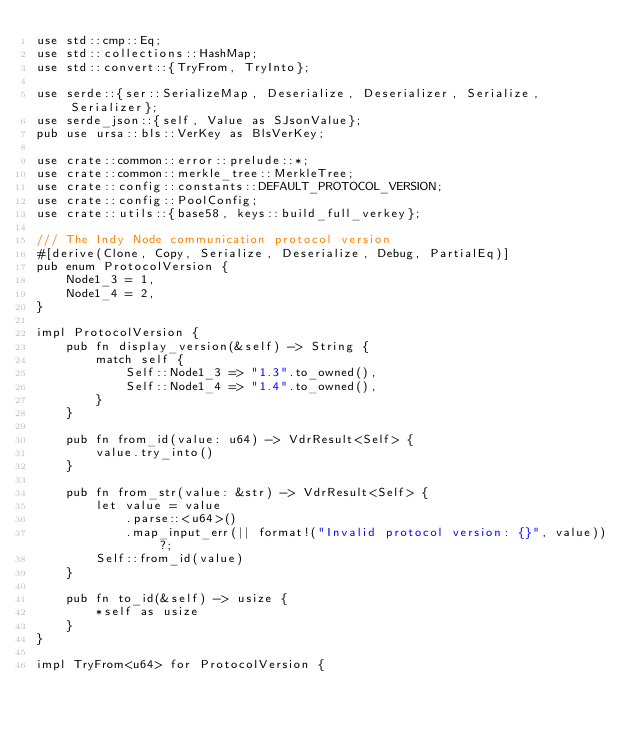Convert code to text. <code><loc_0><loc_0><loc_500><loc_500><_Rust_>use std::cmp::Eq;
use std::collections::HashMap;
use std::convert::{TryFrom, TryInto};

use serde::{ser::SerializeMap, Deserialize, Deserializer, Serialize, Serializer};
use serde_json::{self, Value as SJsonValue};
pub use ursa::bls::VerKey as BlsVerKey;

use crate::common::error::prelude::*;
use crate::common::merkle_tree::MerkleTree;
use crate::config::constants::DEFAULT_PROTOCOL_VERSION;
use crate::config::PoolConfig;
use crate::utils::{base58, keys::build_full_verkey};

/// The Indy Node communication protocol version
#[derive(Clone, Copy, Serialize, Deserialize, Debug, PartialEq)]
pub enum ProtocolVersion {
    Node1_3 = 1,
    Node1_4 = 2,
}

impl ProtocolVersion {
    pub fn display_version(&self) -> String {
        match self {
            Self::Node1_3 => "1.3".to_owned(),
            Self::Node1_4 => "1.4".to_owned(),
        }
    }

    pub fn from_id(value: u64) -> VdrResult<Self> {
        value.try_into()
    }

    pub fn from_str(value: &str) -> VdrResult<Self> {
        let value = value
            .parse::<u64>()
            .map_input_err(|| format!("Invalid protocol version: {}", value))?;
        Self::from_id(value)
    }

    pub fn to_id(&self) -> usize {
        *self as usize
    }
}

impl TryFrom<u64> for ProtocolVersion {</code> 